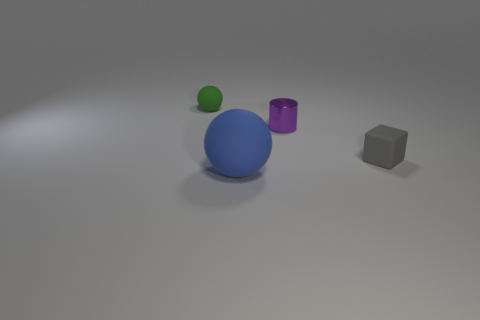Is there anything else that has the same size as the blue sphere?
Offer a very short reply. No. Is there anything else that is made of the same material as the small purple object?
Your answer should be compact. No. What is the color of the ball behind the tiny rubber object that is right of the ball behind the rubber cube?
Your answer should be compact. Green. Are there more large balls that are on the right side of the tiny purple metal cylinder than large blue rubber balls on the left side of the large blue rubber thing?
Offer a very short reply. No. What number of other things are the same size as the block?
Provide a short and direct response. 2. There is a sphere that is in front of the rubber ball that is behind the big blue sphere; what is its material?
Your answer should be compact. Rubber. There is a small green matte sphere; are there any small metallic cylinders to the left of it?
Keep it short and to the point. No. Are there more purple cylinders that are on the right side of the small green rubber thing than small rubber spheres?
Ensure brevity in your answer.  No. Are there any big matte blocks of the same color as the tiny metallic cylinder?
Provide a succinct answer. No. There is a rubber block that is the same size as the green matte ball; what color is it?
Give a very brief answer. Gray. 